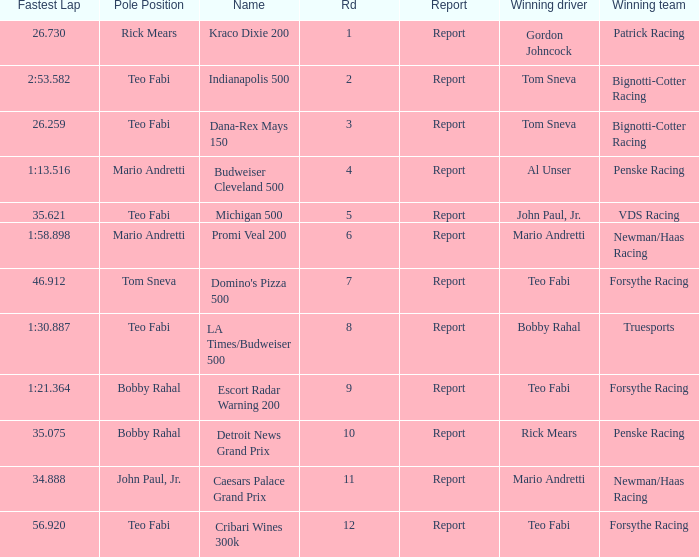What was the fastest lap time in the Escort Radar Warning 200? 1:21.364. 